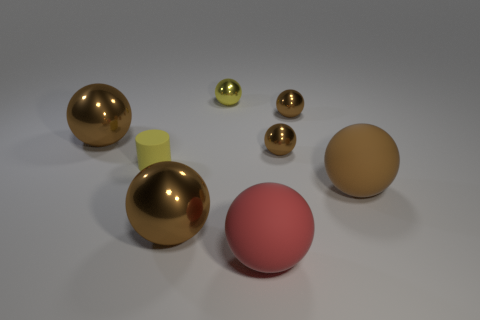What number of brown objects are either cylinders or matte balls?
Make the answer very short. 1. There is a shiny thing that is the same color as the small cylinder; what is its size?
Offer a terse response. Small. Is the number of small yellow metal objects greater than the number of small red metallic blocks?
Your response must be concise. Yes. What number of objects are small objects or large matte objects that are right of the red matte ball?
Your answer should be very brief. 5. What number of other things are there of the same shape as the tiny yellow rubber object?
Ensure brevity in your answer.  0. Is the number of yellow metal spheres in front of the cylinder less than the number of red matte spheres that are behind the big red matte thing?
Your response must be concise. No. Is there anything else that is made of the same material as the yellow sphere?
Offer a very short reply. Yes. There is a yellow thing that is made of the same material as the large red ball; what shape is it?
Offer a very short reply. Cylinder. Is there anything else that is the same color as the tiny cylinder?
Your response must be concise. Yes. The tiny sphere in front of the big brown object behind the yellow matte cylinder is what color?
Keep it short and to the point. Brown. 